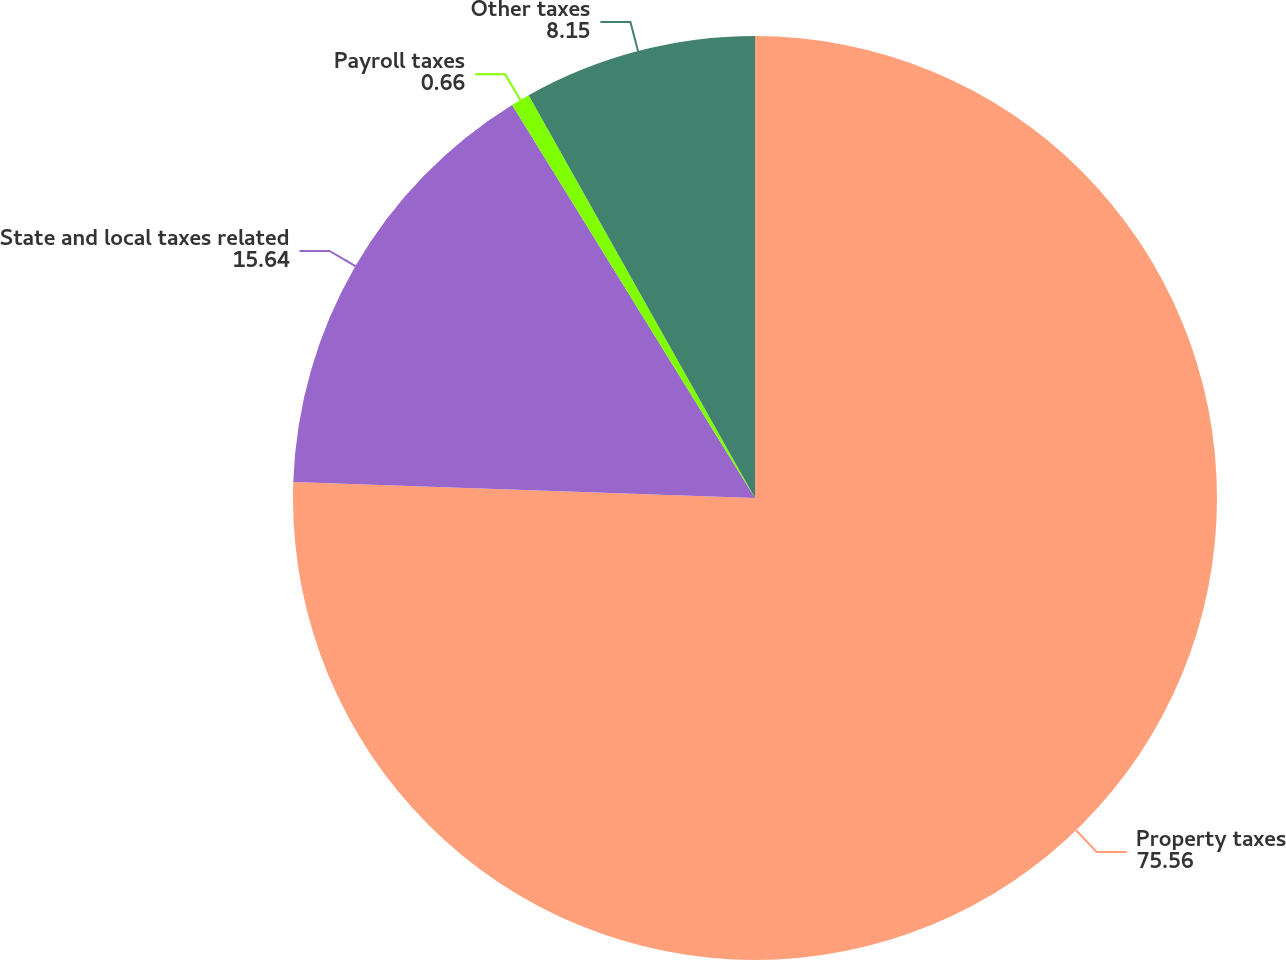Convert chart to OTSL. <chart><loc_0><loc_0><loc_500><loc_500><pie_chart><fcel>Property taxes<fcel>State and local taxes related<fcel>Payroll taxes<fcel>Other taxes<nl><fcel>75.56%<fcel>15.64%<fcel>0.66%<fcel>8.15%<nl></chart> 